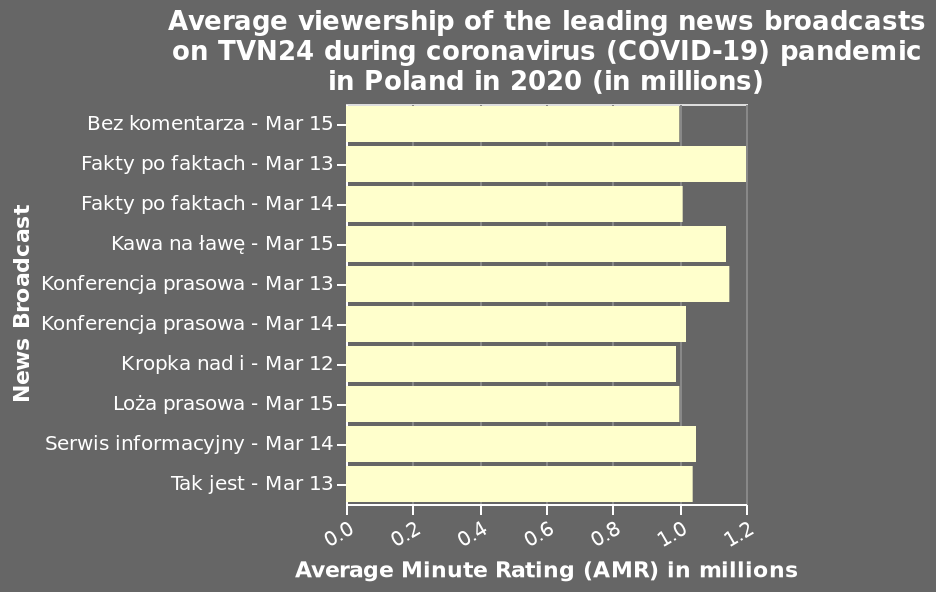<image>
What does the y-axis in the bar diagram represent? The y-axis represents the different news broadcasts on TVN24 during the COVID-19 pandemic in Poland in 2020. What is being measured along the x-axis? The Average Minute Rating (AMR) in millions is being measured along the x-axis. What does the x-axis in the bar diagram represent? The x-axis represents the Average Minute Rating (AMR) in millions on a scale of range 0.0 to 1.2. Is the Average Minute Rating (AMR) in billions being measured along the x-axis? No.The Average Minute Rating (AMR) in millions is being measured along the x-axis. 